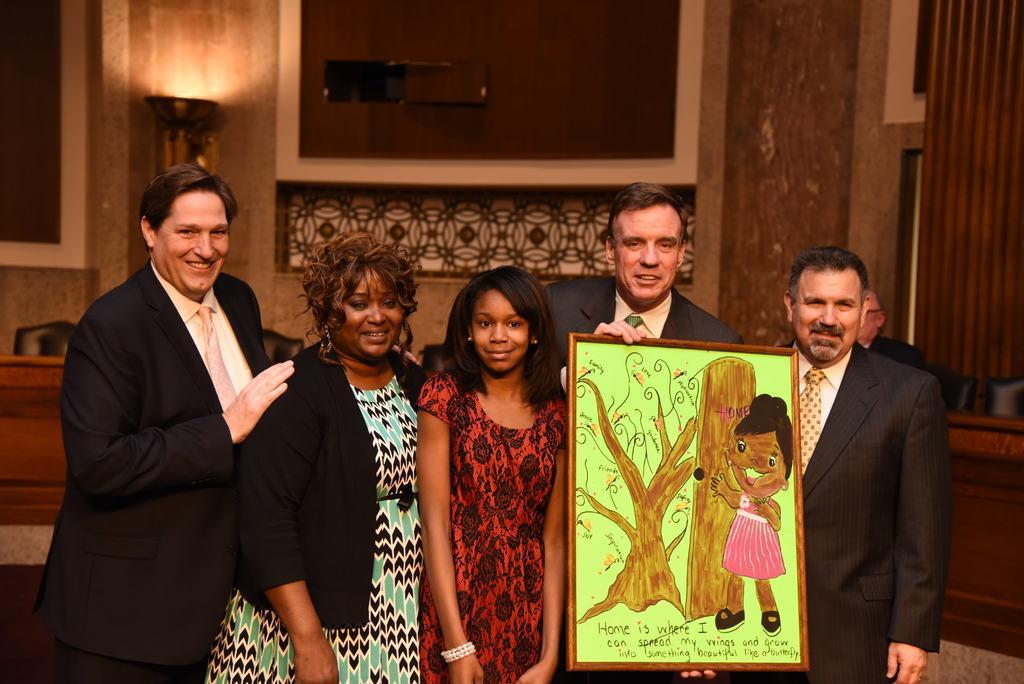Please provide a concise description of this image. In this image we can see five persons in which one of them is holding a frame, in the frame we can see a painting of a person, trees and with some text written on it, there we can see a wall and a light. 